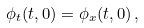Convert formula to latex. <formula><loc_0><loc_0><loc_500><loc_500>\phi _ { t } ( t , 0 ) = \phi _ { x } ( t , 0 ) \, ,</formula> 